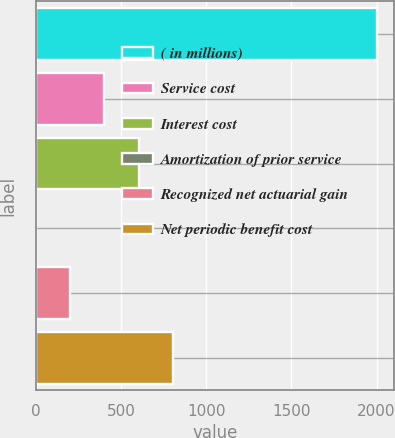Convert chart to OTSL. <chart><loc_0><loc_0><loc_500><loc_500><bar_chart><fcel>( in millions)<fcel>Service cost<fcel>Interest cost<fcel>Amortization of prior service<fcel>Recognized net actuarial gain<fcel>Net periodic benefit cost<nl><fcel>2005<fcel>402.2<fcel>602.55<fcel>1.5<fcel>201.85<fcel>802.9<nl></chart> 